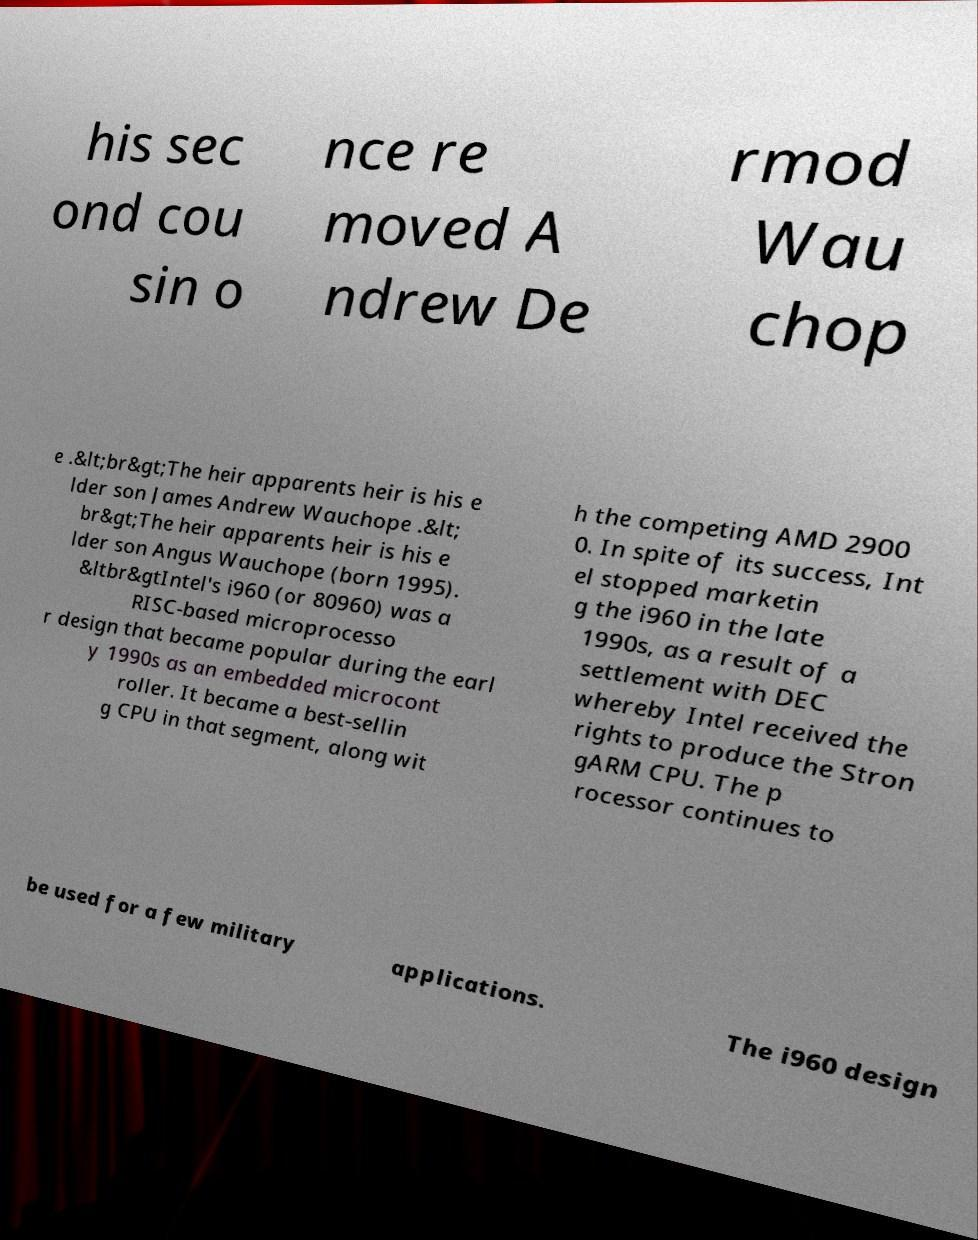Please read and relay the text visible in this image. What does it say? his sec ond cou sin o nce re moved A ndrew De rmod Wau chop e .&lt;br&gt;The heir apparents heir is his e lder son James Andrew Wauchope .&lt; br&gt;The heir apparents heir is his e lder son Angus Wauchope (born 1995). &ltbr&gtIntel's i960 (or 80960) was a RISC-based microprocesso r design that became popular during the earl y 1990s as an embedded microcont roller. It became a best-sellin g CPU in that segment, along wit h the competing AMD 2900 0. In spite of its success, Int el stopped marketin g the i960 in the late 1990s, as a result of a settlement with DEC whereby Intel received the rights to produce the Stron gARM CPU. The p rocessor continues to be used for a few military applications. The i960 design 